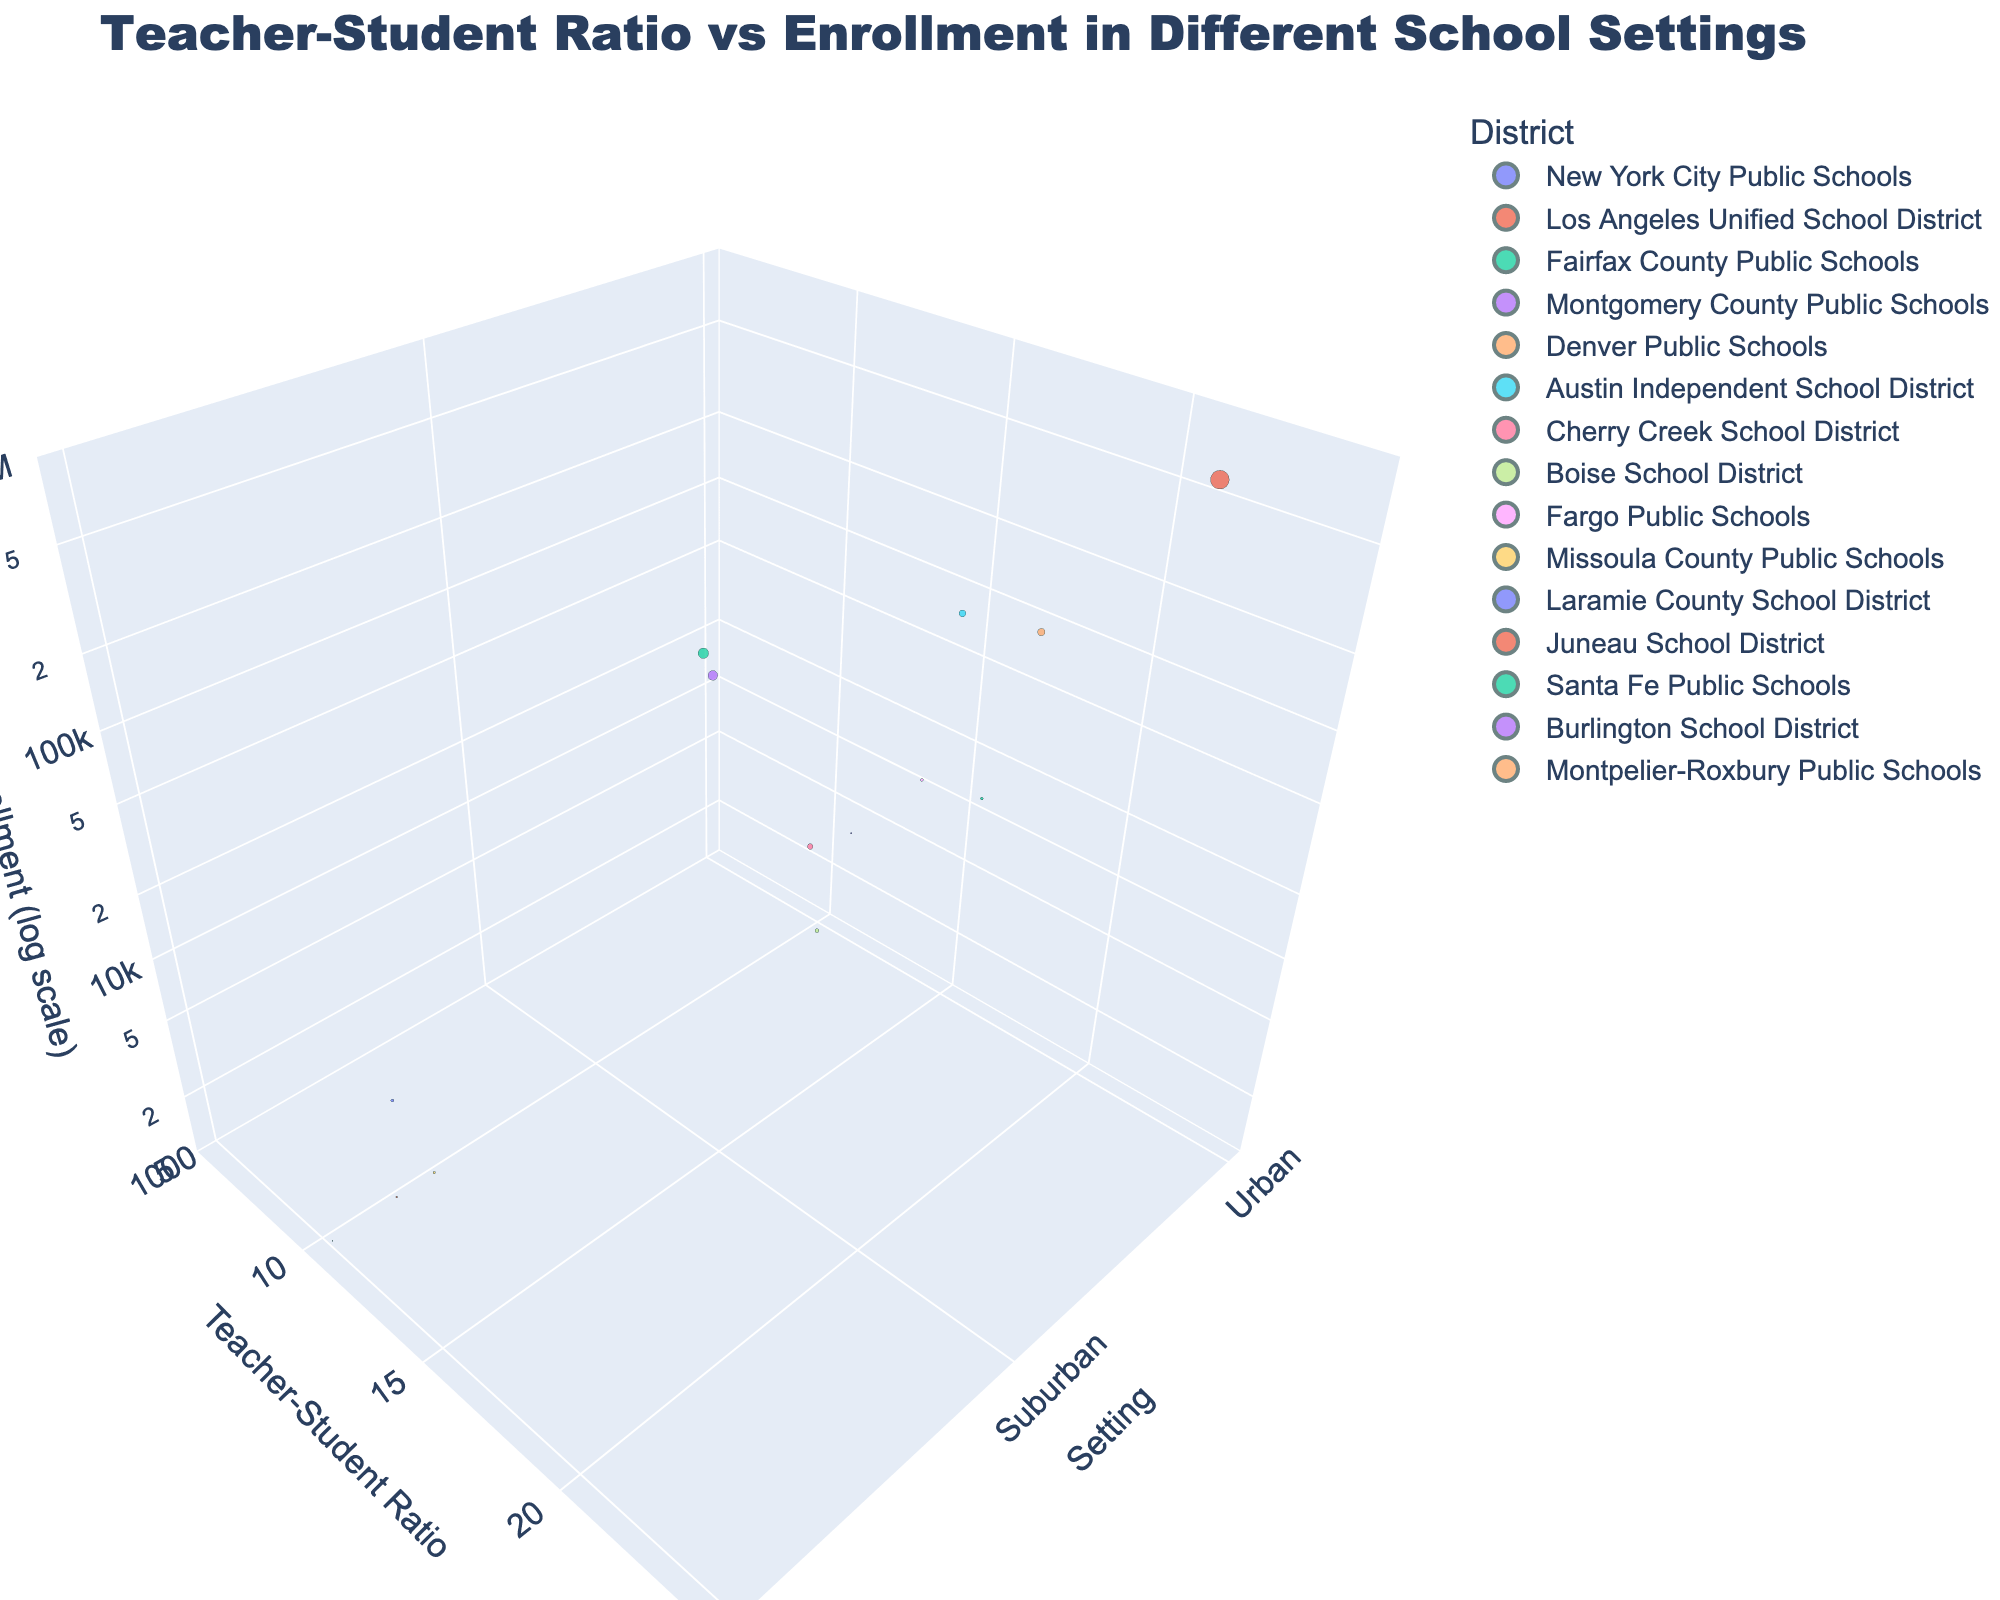How many school districts are represented in the chart? Count the number of distinct bubbles, each representing a different school district.
Answer: 14 Which school district has the highest teacher-to-student ratio? Look for the bubble at the highest position along the y-axis, which represents the teacher-to-student ratio.
Answer: Los Angeles Unified School District What is the setting of the school district with the lowest enrollment? Find the smallest bubble along the z-axis and refer to the x-axis to identify the setting.
Answer: Montpelier-Roxbury Public Schools (Rural) Which urban school district has the smallest enrollment? Among the bubbles located in the 'Urban' setting on the x-axis, find the smallest bubble along the z-axis.
Answer: Burlington School District What is the average teacher-to-student ratio for suburban school districts? Identify all suburban school districts and calculate their average ratio: (14.5 + 14.8 + 17.9 + 18.2) / 4 = 16.35
Answer: 16.35 Compare the teacher-to-student ratios between urban and rural settings. Which setting has a higher average ratio? Calculate the average ratios for each setting: Urban (15.2 + 21.3 + 17.1 + 14.6 + 15.8 + 11.2) / 6 = 15.87, Rural (15.6 + 14.3 + 13.9 + 10.5) / 4 = 13.58. Urban has a higher average ratio.
Answer: Urban Which school district has the largest total enrollment in a suburban setting? Find the largest bubble among those located in the 'Suburban' setting along the x-axis.
Answer: Fairfax County Public Schools Among the three settings (Urban, Suburban, Rural), which has the highest variability in teacher-to-student ratios? Compare the range (difference between maximum and minimum) of ratios in each setting: Urban (21.3 - 11.2 = 10.1), Suburban (18.2 - 14.5 = 3.7), Rural (15.6 - 10.5 = 5.1). Urban has the highest variability.
Answer: Urban How does the enrollment of New York City Public Schools compare to other school districts? Observe that New York City Public Schools have the largest bubble size, indicating the highest enrollment.
Answer: Largest What is the overall trend in teacher-to-student ratios between different settings? Observe that the teacher-to-student ratios and the bubble sizes (enrollment) distribution across Urban, Suburban, and Rural settings.
Answer: Varies across settings, higher in Urban 